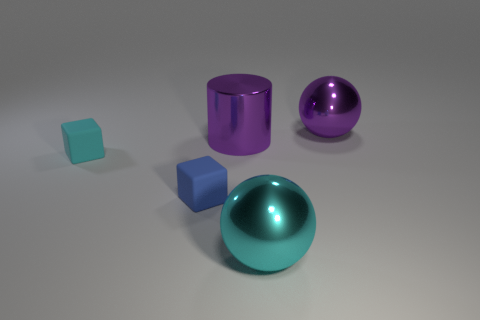What number of balls are left of the big shiny cylinder?
Give a very brief answer. 0. Does the large purple cylinder have the same material as the large purple ball?
Your response must be concise. Yes. How many large objects are right of the large cylinder and behind the cyan cube?
Offer a very short reply. 1. What number of other things are there of the same color as the shiny cylinder?
Make the answer very short. 1. How many blue objects are either large metallic cylinders or tiny metallic cubes?
Your answer should be compact. 0. The cyan shiny sphere is what size?
Provide a short and direct response. Large. What number of matte things are either blue blocks or tiny things?
Provide a succinct answer. 2. Is the number of cyan cubes less than the number of big objects?
Provide a short and direct response. Yes. What number of other objects are there of the same material as the small blue object?
Offer a terse response. 1. What size is the other matte object that is the same shape as the small cyan rubber object?
Make the answer very short. Small. 